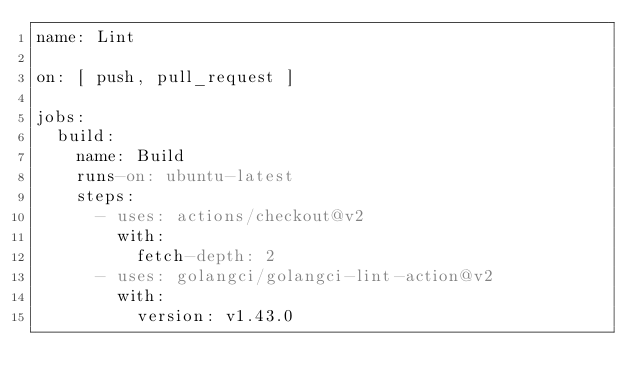<code> <loc_0><loc_0><loc_500><loc_500><_YAML_>name: Lint

on: [ push, pull_request ]

jobs:
  build:
    name: Build
    runs-on: ubuntu-latest
    steps:
      - uses: actions/checkout@v2
        with:
          fetch-depth: 2
      - uses: golangci/golangci-lint-action@v2
        with:
          version: v1.43.0</code> 